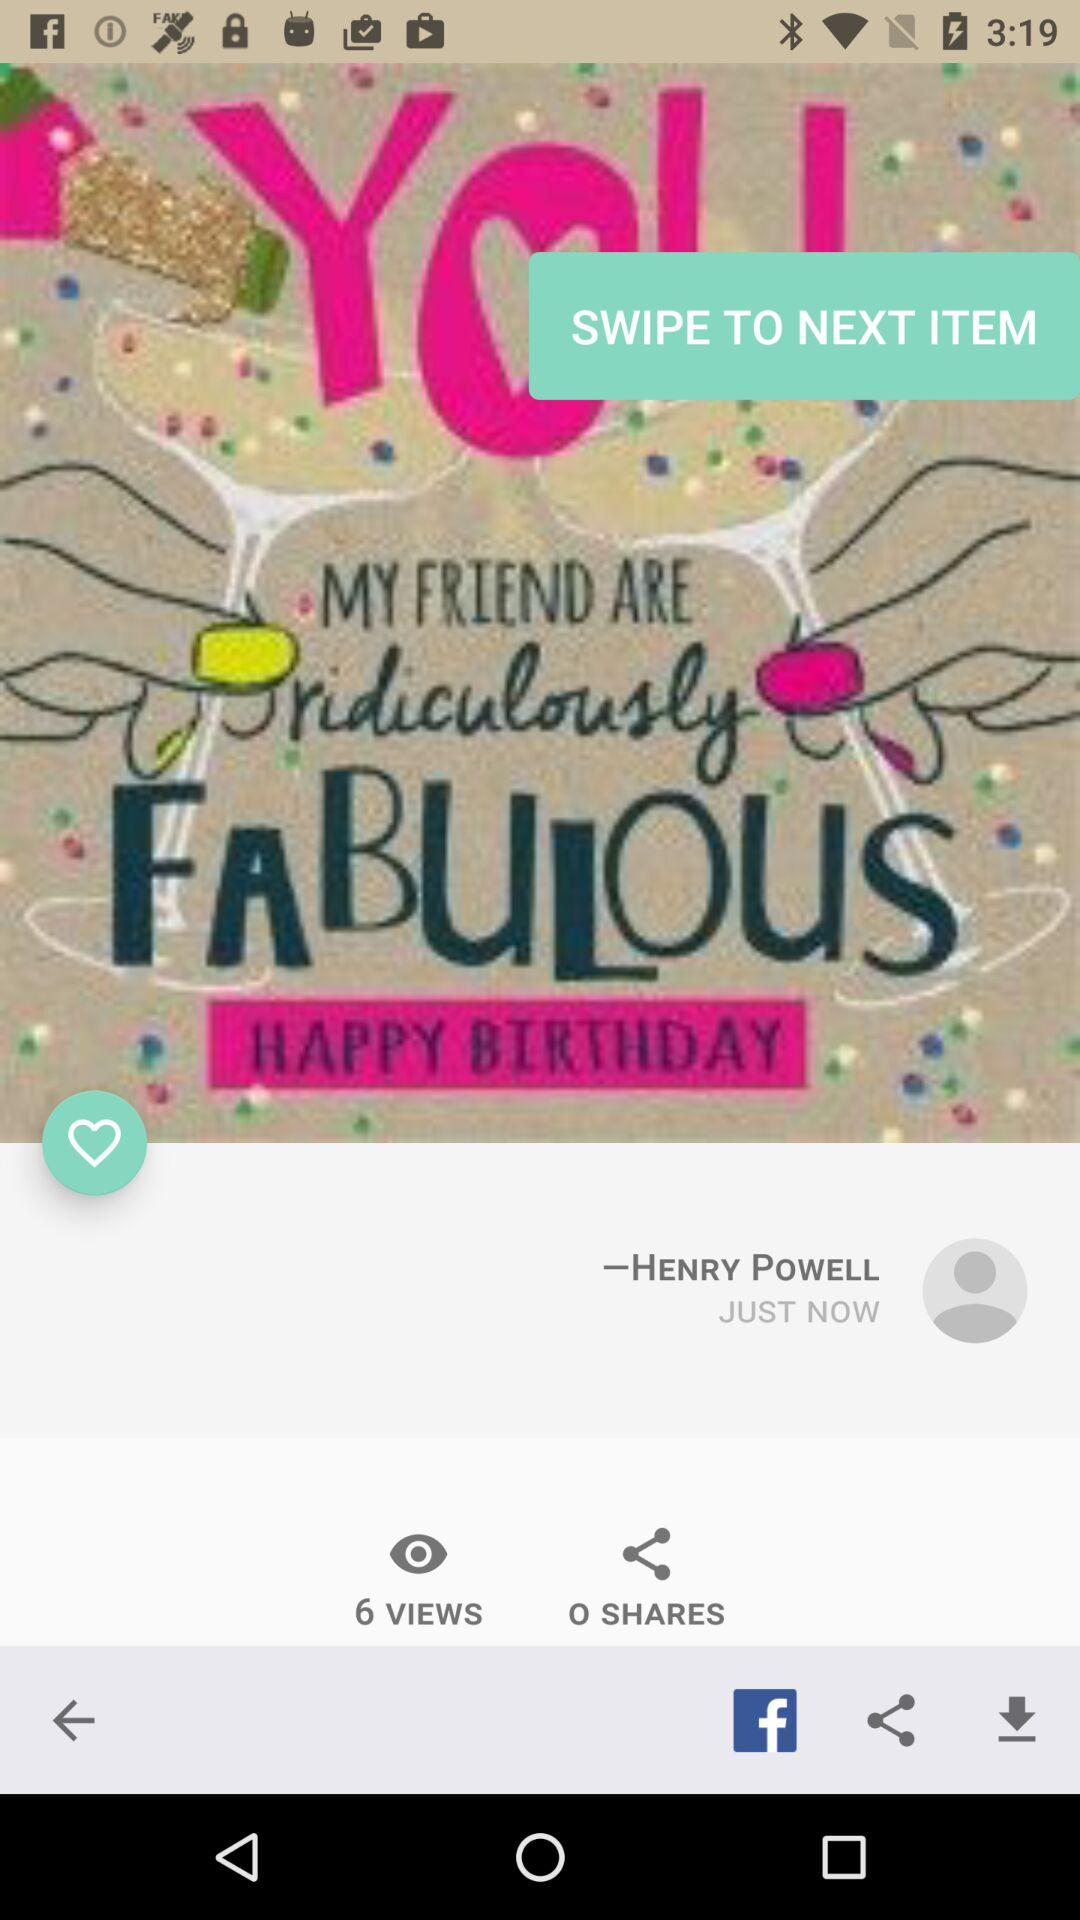How many more views does the post have than shares?
Answer the question using a single word or phrase. 6 